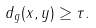<formula> <loc_0><loc_0><loc_500><loc_500>d _ { g } ( x , y ) \geq \tau .</formula> 